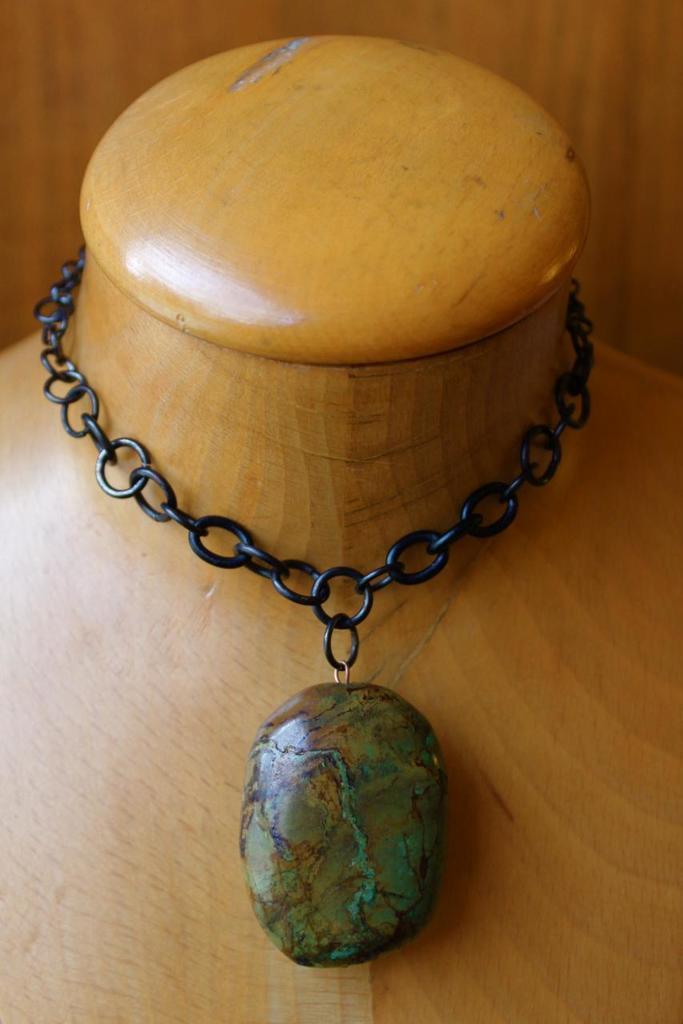Could you give a brief overview of what you see in this image? In this picture there is an ornament on the wooden object. At the back it looks like a wooden wall. 